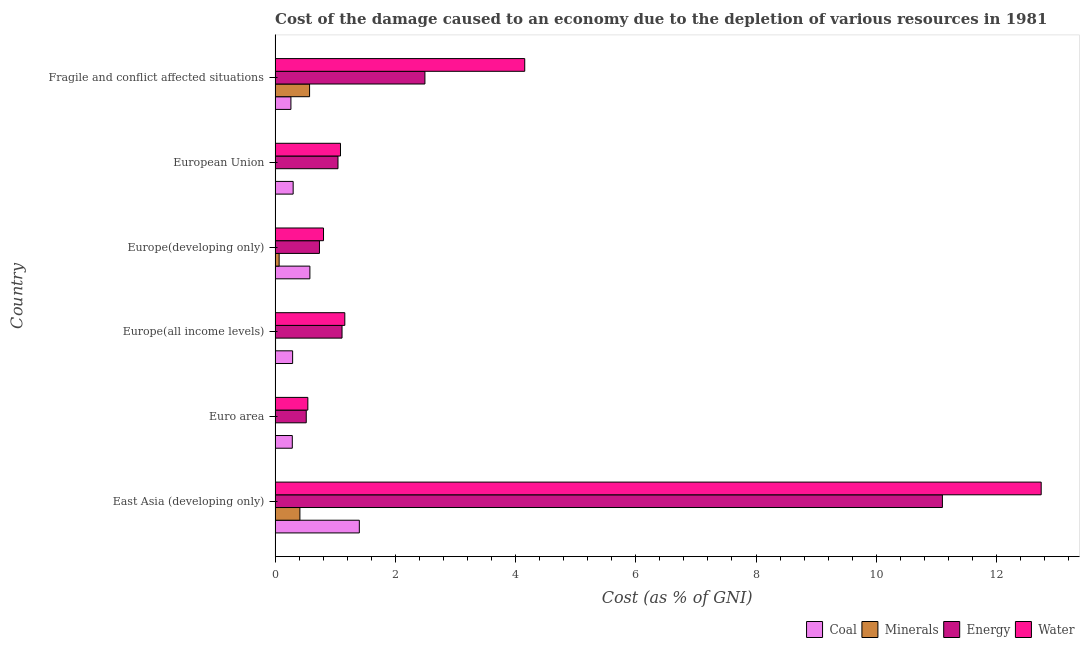How many groups of bars are there?
Offer a terse response. 6. Are the number of bars on each tick of the Y-axis equal?
Offer a terse response. Yes. How many bars are there on the 5th tick from the top?
Provide a short and direct response. 4. What is the label of the 4th group of bars from the top?
Make the answer very short. Europe(all income levels). What is the cost of damage due to depletion of minerals in European Union?
Make the answer very short. 0.01. Across all countries, what is the maximum cost of damage due to depletion of minerals?
Your answer should be very brief. 0.57. Across all countries, what is the minimum cost of damage due to depletion of water?
Ensure brevity in your answer.  0.54. In which country was the cost of damage due to depletion of water maximum?
Your response must be concise. East Asia (developing only). In which country was the cost of damage due to depletion of energy minimum?
Provide a short and direct response. Euro area. What is the total cost of damage due to depletion of minerals in the graph?
Make the answer very short. 1.07. What is the difference between the cost of damage due to depletion of water in Euro area and that in Europe(all income levels)?
Your response must be concise. -0.61. What is the difference between the cost of damage due to depletion of minerals in Europe(all income levels) and the cost of damage due to depletion of energy in East Asia (developing only)?
Your answer should be compact. -11.09. What is the average cost of damage due to depletion of energy per country?
Give a very brief answer. 2.83. What is the difference between the cost of damage due to depletion of energy and cost of damage due to depletion of water in Fragile and conflict affected situations?
Ensure brevity in your answer.  -1.66. In how many countries, is the cost of damage due to depletion of energy greater than 11.2 %?
Make the answer very short. 0. What is the ratio of the cost of damage due to depletion of coal in East Asia (developing only) to that in Europe(developing only)?
Provide a short and direct response. 2.42. Is the cost of damage due to depletion of water in Euro area less than that in Europe(all income levels)?
Offer a terse response. Yes. What is the difference between the highest and the second highest cost of damage due to depletion of water?
Ensure brevity in your answer.  8.59. What is the difference between the highest and the lowest cost of damage due to depletion of energy?
Offer a very short reply. 10.58. Is it the case that in every country, the sum of the cost of damage due to depletion of minerals and cost of damage due to depletion of coal is greater than the sum of cost of damage due to depletion of energy and cost of damage due to depletion of water?
Your answer should be compact. No. What does the 1st bar from the top in Fragile and conflict affected situations represents?
Keep it short and to the point. Water. What does the 4th bar from the bottom in Fragile and conflict affected situations represents?
Offer a very short reply. Water. How many countries are there in the graph?
Provide a short and direct response. 6. What is the difference between two consecutive major ticks on the X-axis?
Offer a very short reply. 2. Are the values on the major ticks of X-axis written in scientific E-notation?
Your answer should be compact. No. How many legend labels are there?
Your response must be concise. 4. What is the title of the graph?
Provide a succinct answer. Cost of the damage caused to an economy due to the depletion of various resources in 1981 . Does "International Monetary Fund" appear as one of the legend labels in the graph?
Offer a very short reply. No. What is the label or title of the X-axis?
Your response must be concise. Cost (as % of GNI). What is the Cost (as % of GNI) in Coal in East Asia (developing only)?
Ensure brevity in your answer.  1.4. What is the Cost (as % of GNI) of Minerals in East Asia (developing only)?
Ensure brevity in your answer.  0.41. What is the Cost (as % of GNI) in Energy in East Asia (developing only)?
Your answer should be compact. 11.1. What is the Cost (as % of GNI) of Water in East Asia (developing only)?
Keep it short and to the point. 12.74. What is the Cost (as % of GNI) of Coal in Euro area?
Give a very brief answer. 0.29. What is the Cost (as % of GNI) of Minerals in Euro area?
Give a very brief answer. 0.01. What is the Cost (as % of GNI) of Energy in Euro area?
Make the answer very short. 0.52. What is the Cost (as % of GNI) in Water in Euro area?
Your answer should be very brief. 0.54. What is the Cost (as % of GNI) of Coal in Europe(all income levels)?
Your answer should be compact. 0.29. What is the Cost (as % of GNI) in Minerals in Europe(all income levels)?
Your response must be concise. 0.01. What is the Cost (as % of GNI) in Energy in Europe(all income levels)?
Keep it short and to the point. 1.11. What is the Cost (as % of GNI) of Water in Europe(all income levels)?
Provide a short and direct response. 1.16. What is the Cost (as % of GNI) of Coal in Europe(developing only)?
Your answer should be compact. 0.58. What is the Cost (as % of GNI) in Minerals in Europe(developing only)?
Your response must be concise. 0.07. What is the Cost (as % of GNI) of Energy in Europe(developing only)?
Provide a succinct answer. 0.74. What is the Cost (as % of GNI) in Water in Europe(developing only)?
Your answer should be very brief. 0.81. What is the Cost (as % of GNI) in Coal in European Union?
Make the answer very short. 0.3. What is the Cost (as % of GNI) in Minerals in European Union?
Your answer should be very brief. 0.01. What is the Cost (as % of GNI) of Energy in European Union?
Your response must be concise. 1.05. What is the Cost (as % of GNI) in Water in European Union?
Keep it short and to the point. 1.09. What is the Cost (as % of GNI) of Coal in Fragile and conflict affected situations?
Offer a very short reply. 0.26. What is the Cost (as % of GNI) of Minerals in Fragile and conflict affected situations?
Give a very brief answer. 0.57. What is the Cost (as % of GNI) in Energy in Fragile and conflict affected situations?
Provide a short and direct response. 2.49. What is the Cost (as % of GNI) of Water in Fragile and conflict affected situations?
Your response must be concise. 4.15. Across all countries, what is the maximum Cost (as % of GNI) of Coal?
Your response must be concise. 1.4. Across all countries, what is the maximum Cost (as % of GNI) of Minerals?
Offer a very short reply. 0.57. Across all countries, what is the maximum Cost (as % of GNI) of Energy?
Keep it short and to the point. 11.1. Across all countries, what is the maximum Cost (as % of GNI) of Water?
Your response must be concise. 12.74. Across all countries, what is the minimum Cost (as % of GNI) of Coal?
Keep it short and to the point. 0.26. Across all countries, what is the minimum Cost (as % of GNI) in Minerals?
Provide a short and direct response. 0.01. Across all countries, what is the minimum Cost (as % of GNI) of Energy?
Keep it short and to the point. 0.52. Across all countries, what is the minimum Cost (as % of GNI) in Water?
Your response must be concise. 0.54. What is the total Cost (as % of GNI) of Coal in the graph?
Keep it short and to the point. 3.12. What is the total Cost (as % of GNI) in Minerals in the graph?
Provide a short and direct response. 1.07. What is the total Cost (as % of GNI) of Energy in the graph?
Ensure brevity in your answer.  17.01. What is the total Cost (as % of GNI) in Water in the graph?
Your answer should be compact. 20.49. What is the difference between the Cost (as % of GNI) in Coal in East Asia (developing only) and that in Euro area?
Provide a succinct answer. 1.11. What is the difference between the Cost (as % of GNI) in Minerals in East Asia (developing only) and that in Euro area?
Make the answer very short. 0.41. What is the difference between the Cost (as % of GNI) of Energy in East Asia (developing only) and that in Euro area?
Give a very brief answer. 10.58. What is the difference between the Cost (as % of GNI) of Water in East Asia (developing only) and that in Euro area?
Offer a very short reply. 12.2. What is the difference between the Cost (as % of GNI) in Coal in East Asia (developing only) and that in Europe(all income levels)?
Offer a terse response. 1.11. What is the difference between the Cost (as % of GNI) of Minerals in East Asia (developing only) and that in Europe(all income levels)?
Keep it short and to the point. 0.41. What is the difference between the Cost (as % of GNI) in Energy in East Asia (developing only) and that in Europe(all income levels)?
Offer a very short reply. 9.99. What is the difference between the Cost (as % of GNI) of Water in East Asia (developing only) and that in Europe(all income levels)?
Keep it short and to the point. 11.58. What is the difference between the Cost (as % of GNI) of Coal in East Asia (developing only) and that in Europe(developing only)?
Your answer should be compact. 0.82. What is the difference between the Cost (as % of GNI) in Minerals in East Asia (developing only) and that in Europe(developing only)?
Your answer should be very brief. 0.35. What is the difference between the Cost (as % of GNI) of Energy in East Asia (developing only) and that in Europe(developing only)?
Provide a succinct answer. 10.36. What is the difference between the Cost (as % of GNI) in Water in East Asia (developing only) and that in Europe(developing only)?
Give a very brief answer. 11.94. What is the difference between the Cost (as % of GNI) of Coal in East Asia (developing only) and that in European Union?
Provide a succinct answer. 1.1. What is the difference between the Cost (as % of GNI) of Minerals in East Asia (developing only) and that in European Union?
Provide a short and direct response. 0.41. What is the difference between the Cost (as % of GNI) of Energy in East Asia (developing only) and that in European Union?
Provide a succinct answer. 10.05. What is the difference between the Cost (as % of GNI) of Water in East Asia (developing only) and that in European Union?
Provide a short and direct response. 11.66. What is the difference between the Cost (as % of GNI) in Coal in East Asia (developing only) and that in Fragile and conflict affected situations?
Provide a succinct answer. 1.14. What is the difference between the Cost (as % of GNI) of Minerals in East Asia (developing only) and that in Fragile and conflict affected situations?
Provide a succinct answer. -0.16. What is the difference between the Cost (as % of GNI) in Energy in East Asia (developing only) and that in Fragile and conflict affected situations?
Your answer should be compact. 8.61. What is the difference between the Cost (as % of GNI) of Water in East Asia (developing only) and that in Fragile and conflict affected situations?
Your answer should be very brief. 8.59. What is the difference between the Cost (as % of GNI) in Coal in Euro area and that in Europe(all income levels)?
Provide a short and direct response. -0.01. What is the difference between the Cost (as % of GNI) in Minerals in Euro area and that in Europe(all income levels)?
Provide a short and direct response. -0. What is the difference between the Cost (as % of GNI) of Energy in Euro area and that in Europe(all income levels)?
Provide a succinct answer. -0.6. What is the difference between the Cost (as % of GNI) in Water in Euro area and that in Europe(all income levels)?
Your answer should be very brief. -0.61. What is the difference between the Cost (as % of GNI) of Coal in Euro area and that in Europe(developing only)?
Provide a succinct answer. -0.29. What is the difference between the Cost (as % of GNI) of Minerals in Euro area and that in Europe(developing only)?
Make the answer very short. -0.06. What is the difference between the Cost (as % of GNI) of Energy in Euro area and that in Europe(developing only)?
Ensure brevity in your answer.  -0.22. What is the difference between the Cost (as % of GNI) in Water in Euro area and that in Europe(developing only)?
Make the answer very short. -0.26. What is the difference between the Cost (as % of GNI) in Coal in Euro area and that in European Union?
Provide a short and direct response. -0.01. What is the difference between the Cost (as % of GNI) in Minerals in Euro area and that in European Union?
Your answer should be very brief. -0. What is the difference between the Cost (as % of GNI) in Energy in Euro area and that in European Union?
Ensure brevity in your answer.  -0.53. What is the difference between the Cost (as % of GNI) in Water in Euro area and that in European Union?
Offer a very short reply. -0.54. What is the difference between the Cost (as % of GNI) of Coal in Euro area and that in Fragile and conflict affected situations?
Your answer should be compact. 0.02. What is the difference between the Cost (as % of GNI) in Minerals in Euro area and that in Fragile and conflict affected situations?
Give a very brief answer. -0.57. What is the difference between the Cost (as % of GNI) of Energy in Euro area and that in Fragile and conflict affected situations?
Provide a succinct answer. -1.97. What is the difference between the Cost (as % of GNI) in Water in Euro area and that in Fragile and conflict affected situations?
Give a very brief answer. -3.61. What is the difference between the Cost (as % of GNI) of Coal in Europe(all income levels) and that in Europe(developing only)?
Provide a succinct answer. -0.29. What is the difference between the Cost (as % of GNI) in Minerals in Europe(all income levels) and that in Europe(developing only)?
Give a very brief answer. -0.06. What is the difference between the Cost (as % of GNI) of Energy in Europe(all income levels) and that in Europe(developing only)?
Ensure brevity in your answer.  0.38. What is the difference between the Cost (as % of GNI) in Water in Europe(all income levels) and that in Europe(developing only)?
Offer a terse response. 0.35. What is the difference between the Cost (as % of GNI) in Coal in Europe(all income levels) and that in European Union?
Provide a short and direct response. -0.01. What is the difference between the Cost (as % of GNI) of Minerals in Europe(all income levels) and that in European Union?
Provide a short and direct response. 0. What is the difference between the Cost (as % of GNI) in Energy in Europe(all income levels) and that in European Union?
Your answer should be very brief. 0.07. What is the difference between the Cost (as % of GNI) in Water in Europe(all income levels) and that in European Union?
Ensure brevity in your answer.  0.07. What is the difference between the Cost (as % of GNI) of Coal in Europe(all income levels) and that in Fragile and conflict affected situations?
Your response must be concise. 0.03. What is the difference between the Cost (as % of GNI) of Minerals in Europe(all income levels) and that in Fragile and conflict affected situations?
Offer a terse response. -0.57. What is the difference between the Cost (as % of GNI) of Energy in Europe(all income levels) and that in Fragile and conflict affected situations?
Provide a succinct answer. -1.38. What is the difference between the Cost (as % of GNI) of Water in Europe(all income levels) and that in Fragile and conflict affected situations?
Give a very brief answer. -2.99. What is the difference between the Cost (as % of GNI) of Coal in Europe(developing only) and that in European Union?
Offer a terse response. 0.28. What is the difference between the Cost (as % of GNI) of Minerals in Europe(developing only) and that in European Union?
Your answer should be compact. 0.06. What is the difference between the Cost (as % of GNI) of Energy in Europe(developing only) and that in European Union?
Make the answer very short. -0.31. What is the difference between the Cost (as % of GNI) of Water in Europe(developing only) and that in European Union?
Offer a terse response. -0.28. What is the difference between the Cost (as % of GNI) in Coal in Europe(developing only) and that in Fragile and conflict affected situations?
Your response must be concise. 0.32. What is the difference between the Cost (as % of GNI) in Minerals in Europe(developing only) and that in Fragile and conflict affected situations?
Your answer should be very brief. -0.51. What is the difference between the Cost (as % of GNI) of Energy in Europe(developing only) and that in Fragile and conflict affected situations?
Your response must be concise. -1.75. What is the difference between the Cost (as % of GNI) of Water in Europe(developing only) and that in Fragile and conflict affected situations?
Provide a succinct answer. -3.35. What is the difference between the Cost (as % of GNI) in Coal in European Union and that in Fragile and conflict affected situations?
Provide a short and direct response. 0.04. What is the difference between the Cost (as % of GNI) in Minerals in European Union and that in Fragile and conflict affected situations?
Your response must be concise. -0.57. What is the difference between the Cost (as % of GNI) of Energy in European Union and that in Fragile and conflict affected situations?
Your response must be concise. -1.45. What is the difference between the Cost (as % of GNI) in Water in European Union and that in Fragile and conflict affected situations?
Provide a succinct answer. -3.06. What is the difference between the Cost (as % of GNI) in Coal in East Asia (developing only) and the Cost (as % of GNI) in Minerals in Euro area?
Offer a terse response. 1.4. What is the difference between the Cost (as % of GNI) of Coal in East Asia (developing only) and the Cost (as % of GNI) of Energy in Euro area?
Your answer should be very brief. 0.88. What is the difference between the Cost (as % of GNI) of Coal in East Asia (developing only) and the Cost (as % of GNI) of Water in Euro area?
Your answer should be compact. 0.86. What is the difference between the Cost (as % of GNI) in Minerals in East Asia (developing only) and the Cost (as % of GNI) in Energy in Euro area?
Provide a succinct answer. -0.11. What is the difference between the Cost (as % of GNI) in Minerals in East Asia (developing only) and the Cost (as % of GNI) in Water in Euro area?
Your response must be concise. -0.13. What is the difference between the Cost (as % of GNI) in Energy in East Asia (developing only) and the Cost (as % of GNI) in Water in Euro area?
Make the answer very short. 10.55. What is the difference between the Cost (as % of GNI) in Coal in East Asia (developing only) and the Cost (as % of GNI) in Minerals in Europe(all income levels)?
Keep it short and to the point. 1.39. What is the difference between the Cost (as % of GNI) of Coal in East Asia (developing only) and the Cost (as % of GNI) of Energy in Europe(all income levels)?
Keep it short and to the point. 0.29. What is the difference between the Cost (as % of GNI) of Coal in East Asia (developing only) and the Cost (as % of GNI) of Water in Europe(all income levels)?
Provide a succinct answer. 0.24. What is the difference between the Cost (as % of GNI) in Minerals in East Asia (developing only) and the Cost (as % of GNI) in Energy in Europe(all income levels)?
Keep it short and to the point. -0.7. What is the difference between the Cost (as % of GNI) of Minerals in East Asia (developing only) and the Cost (as % of GNI) of Water in Europe(all income levels)?
Offer a terse response. -0.75. What is the difference between the Cost (as % of GNI) in Energy in East Asia (developing only) and the Cost (as % of GNI) in Water in Europe(all income levels)?
Keep it short and to the point. 9.94. What is the difference between the Cost (as % of GNI) of Coal in East Asia (developing only) and the Cost (as % of GNI) of Minerals in Europe(developing only)?
Keep it short and to the point. 1.33. What is the difference between the Cost (as % of GNI) in Coal in East Asia (developing only) and the Cost (as % of GNI) in Energy in Europe(developing only)?
Offer a terse response. 0.66. What is the difference between the Cost (as % of GNI) in Coal in East Asia (developing only) and the Cost (as % of GNI) in Water in Europe(developing only)?
Make the answer very short. 0.6. What is the difference between the Cost (as % of GNI) in Minerals in East Asia (developing only) and the Cost (as % of GNI) in Energy in Europe(developing only)?
Make the answer very short. -0.33. What is the difference between the Cost (as % of GNI) of Minerals in East Asia (developing only) and the Cost (as % of GNI) of Water in Europe(developing only)?
Provide a succinct answer. -0.39. What is the difference between the Cost (as % of GNI) of Energy in East Asia (developing only) and the Cost (as % of GNI) of Water in Europe(developing only)?
Offer a terse response. 10.29. What is the difference between the Cost (as % of GNI) in Coal in East Asia (developing only) and the Cost (as % of GNI) in Minerals in European Union?
Provide a short and direct response. 1.39. What is the difference between the Cost (as % of GNI) in Coal in East Asia (developing only) and the Cost (as % of GNI) in Energy in European Union?
Your answer should be compact. 0.36. What is the difference between the Cost (as % of GNI) of Coal in East Asia (developing only) and the Cost (as % of GNI) of Water in European Union?
Offer a terse response. 0.31. What is the difference between the Cost (as % of GNI) in Minerals in East Asia (developing only) and the Cost (as % of GNI) in Energy in European Union?
Offer a terse response. -0.63. What is the difference between the Cost (as % of GNI) of Minerals in East Asia (developing only) and the Cost (as % of GNI) of Water in European Union?
Make the answer very short. -0.68. What is the difference between the Cost (as % of GNI) of Energy in East Asia (developing only) and the Cost (as % of GNI) of Water in European Union?
Your answer should be very brief. 10.01. What is the difference between the Cost (as % of GNI) in Coal in East Asia (developing only) and the Cost (as % of GNI) in Minerals in Fragile and conflict affected situations?
Offer a very short reply. 0.83. What is the difference between the Cost (as % of GNI) of Coal in East Asia (developing only) and the Cost (as % of GNI) of Energy in Fragile and conflict affected situations?
Ensure brevity in your answer.  -1.09. What is the difference between the Cost (as % of GNI) in Coal in East Asia (developing only) and the Cost (as % of GNI) in Water in Fragile and conflict affected situations?
Offer a very short reply. -2.75. What is the difference between the Cost (as % of GNI) in Minerals in East Asia (developing only) and the Cost (as % of GNI) in Energy in Fragile and conflict affected situations?
Offer a terse response. -2.08. What is the difference between the Cost (as % of GNI) in Minerals in East Asia (developing only) and the Cost (as % of GNI) in Water in Fragile and conflict affected situations?
Ensure brevity in your answer.  -3.74. What is the difference between the Cost (as % of GNI) in Energy in East Asia (developing only) and the Cost (as % of GNI) in Water in Fragile and conflict affected situations?
Offer a terse response. 6.95. What is the difference between the Cost (as % of GNI) in Coal in Euro area and the Cost (as % of GNI) in Minerals in Europe(all income levels)?
Offer a very short reply. 0.28. What is the difference between the Cost (as % of GNI) in Coal in Euro area and the Cost (as % of GNI) in Energy in Europe(all income levels)?
Your answer should be compact. -0.83. What is the difference between the Cost (as % of GNI) of Coal in Euro area and the Cost (as % of GNI) of Water in Europe(all income levels)?
Your answer should be compact. -0.87. What is the difference between the Cost (as % of GNI) in Minerals in Euro area and the Cost (as % of GNI) in Energy in Europe(all income levels)?
Provide a short and direct response. -1.11. What is the difference between the Cost (as % of GNI) in Minerals in Euro area and the Cost (as % of GNI) in Water in Europe(all income levels)?
Offer a terse response. -1.15. What is the difference between the Cost (as % of GNI) of Energy in Euro area and the Cost (as % of GNI) of Water in Europe(all income levels)?
Your answer should be very brief. -0.64. What is the difference between the Cost (as % of GNI) of Coal in Euro area and the Cost (as % of GNI) of Minerals in Europe(developing only)?
Keep it short and to the point. 0.22. What is the difference between the Cost (as % of GNI) in Coal in Euro area and the Cost (as % of GNI) in Energy in Europe(developing only)?
Keep it short and to the point. -0.45. What is the difference between the Cost (as % of GNI) in Coal in Euro area and the Cost (as % of GNI) in Water in Europe(developing only)?
Keep it short and to the point. -0.52. What is the difference between the Cost (as % of GNI) of Minerals in Euro area and the Cost (as % of GNI) of Energy in Europe(developing only)?
Keep it short and to the point. -0.73. What is the difference between the Cost (as % of GNI) in Minerals in Euro area and the Cost (as % of GNI) in Water in Europe(developing only)?
Keep it short and to the point. -0.8. What is the difference between the Cost (as % of GNI) of Energy in Euro area and the Cost (as % of GNI) of Water in Europe(developing only)?
Your answer should be very brief. -0.29. What is the difference between the Cost (as % of GNI) in Coal in Euro area and the Cost (as % of GNI) in Minerals in European Union?
Ensure brevity in your answer.  0.28. What is the difference between the Cost (as % of GNI) in Coal in Euro area and the Cost (as % of GNI) in Energy in European Union?
Offer a terse response. -0.76. What is the difference between the Cost (as % of GNI) in Coal in Euro area and the Cost (as % of GNI) in Water in European Union?
Ensure brevity in your answer.  -0.8. What is the difference between the Cost (as % of GNI) in Minerals in Euro area and the Cost (as % of GNI) in Energy in European Union?
Your answer should be very brief. -1.04. What is the difference between the Cost (as % of GNI) in Minerals in Euro area and the Cost (as % of GNI) in Water in European Union?
Offer a terse response. -1.08. What is the difference between the Cost (as % of GNI) of Energy in Euro area and the Cost (as % of GNI) of Water in European Union?
Provide a short and direct response. -0.57. What is the difference between the Cost (as % of GNI) of Coal in Euro area and the Cost (as % of GNI) of Minerals in Fragile and conflict affected situations?
Your answer should be compact. -0.29. What is the difference between the Cost (as % of GNI) of Coal in Euro area and the Cost (as % of GNI) of Energy in Fragile and conflict affected situations?
Provide a succinct answer. -2.21. What is the difference between the Cost (as % of GNI) of Coal in Euro area and the Cost (as % of GNI) of Water in Fragile and conflict affected situations?
Your answer should be very brief. -3.87. What is the difference between the Cost (as % of GNI) in Minerals in Euro area and the Cost (as % of GNI) in Energy in Fragile and conflict affected situations?
Give a very brief answer. -2.49. What is the difference between the Cost (as % of GNI) of Minerals in Euro area and the Cost (as % of GNI) of Water in Fragile and conflict affected situations?
Your answer should be compact. -4.15. What is the difference between the Cost (as % of GNI) in Energy in Euro area and the Cost (as % of GNI) in Water in Fragile and conflict affected situations?
Ensure brevity in your answer.  -3.63. What is the difference between the Cost (as % of GNI) in Coal in Europe(all income levels) and the Cost (as % of GNI) in Minerals in Europe(developing only)?
Your answer should be compact. 0.22. What is the difference between the Cost (as % of GNI) of Coal in Europe(all income levels) and the Cost (as % of GNI) of Energy in Europe(developing only)?
Offer a terse response. -0.45. What is the difference between the Cost (as % of GNI) in Coal in Europe(all income levels) and the Cost (as % of GNI) in Water in Europe(developing only)?
Ensure brevity in your answer.  -0.51. What is the difference between the Cost (as % of GNI) of Minerals in Europe(all income levels) and the Cost (as % of GNI) of Energy in Europe(developing only)?
Provide a succinct answer. -0.73. What is the difference between the Cost (as % of GNI) of Minerals in Europe(all income levels) and the Cost (as % of GNI) of Water in Europe(developing only)?
Provide a short and direct response. -0.8. What is the difference between the Cost (as % of GNI) of Energy in Europe(all income levels) and the Cost (as % of GNI) of Water in Europe(developing only)?
Your answer should be very brief. 0.31. What is the difference between the Cost (as % of GNI) in Coal in Europe(all income levels) and the Cost (as % of GNI) in Minerals in European Union?
Provide a short and direct response. 0.28. What is the difference between the Cost (as % of GNI) of Coal in Europe(all income levels) and the Cost (as % of GNI) of Energy in European Union?
Make the answer very short. -0.75. What is the difference between the Cost (as % of GNI) in Coal in Europe(all income levels) and the Cost (as % of GNI) in Water in European Union?
Give a very brief answer. -0.8. What is the difference between the Cost (as % of GNI) in Minerals in Europe(all income levels) and the Cost (as % of GNI) in Energy in European Union?
Provide a succinct answer. -1.04. What is the difference between the Cost (as % of GNI) of Minerals in Europe(all income levels) and the Cost (as % of GNI) of Water in European Union?
Your answer should be very brief. -1.08. What is the difference between the Cost (as % of GNI) of Energy in Europe(all income levels) and the Cost (as % of GNI) of Water in European Union?
Keep it short and to the point. 0.03. What is the difference between the Cost (as % of GNI) of Coal in Europe(all income levels) and the Cost (as % of GNI) of Minerals in Fragile and conflict affected situations?
Keep it short and to the point. -0.28. What is the difference between the Cost (as % of GNI) in Coal in Europe(all income levels) and the Cost (as % of GNI) in Energy in Fragile and conflict affected situations?
Your response must be concise. -2.2. What is the difference between the Cost (as % of GNI) in Coal in Europe(all income levels) and the Cost (as % of GNI) in Water in Fragile and conflict affected situations?
Your answer should be compact. -3.86. What is the difference between the Cost (as % of GNI) in Minerals in Europe(all income levels) and the Cost (as % of GNI) in Energy in Fragile and conflict affected situations?
Your answer should be compact. -2.48. What is the difference between the Cost (as % of GNI) in Minerals in Europe(all income levels) and the Cost (as % of GNI) in Water in Fragile and conflict affected situations?
Provide a short and direct response. -4.14. What is the difference between the Cost (as % of GNI) in Energy in Europe(all income levels) and the Cost (as % of GNI) in Water in Fragile and conflict affected situations?
Keep it short and to the point. -3.04. What is the difference between the Cost (as % of GNI) of Coal in Europe(developing only) and the Cost (as % of GNI) of Minerals in European Union?
Your response must be concise. 0.57. What is the difference between the Cost (as % of GNI) in Coal in Europe(developing only) and the Cost (as % of GNI) in Energy in European Union?
Your response must be concise. -0.47. What is the difference between the Cost (as % of GNI) of Coal in Europe(developing only) and the Cost (as % of GNI) of Water in European Union?
Your answer should be compact. -0.51. What is the difference between the Cost (as % of GNI) in Minerals in Europe(developing only) and the Cost (as % of GNI) in Energy in European Union?
Offer a very short reply. -0.98. What is the difference between the Cost (as % of GNI) of Minerals in Europe(developing only) and the Cost (as % of GNI) of Water in European Union?
Keep it short and to the point. -1.02. What is the difference between the Cost (as % of GNI) of Energy in Europe(developing only) and the Cost (as % of GNI) of Water in European Union?
Give a very brief answer. -0.35. What is the difference between the Cost (as % of GNI) of Coal in Europe(developing only) and the Cost (as % of GNI) of Minerals in Fragile and conflict affected situations?
Give a very brief answer. 0.01. What is the difference between the Cost (as % of GNI) of Coal in Europe(developing only) and the Cost (as % of GNI) of Energy in Fragile and conflict affected situations?
Keep it short and to the point. -1.91. What is the difference between the Cost (as % of GNI) in Coal in Europe(developing only) and the Cost (as % of GNI) in Water in Fragile and conflict affected situations?
Give a very brief answer. -3.57. What is the difference between the Cost (as % of GNI) of Minerals in Europe(developing only) and the Cost (as % of GNI) of Energy in Fragile and conflict affected situations?
Offer a very short reply. -2.42. What is the difference between the Cost (as % of GNI) in Minerals in Europe(developing only) and the Cost (as % of GNI) in Water in Fragile and conflict affected situations?
Ensure brevity in your answer.  -4.09. What is the difference between the Cost (as % of GNI) of Energy in Europe(developing only) and the Cost (as % of GNI) of Water in Fragile and conflict affected situations?
Offer a terse response. -3.41. What is the difference between the Cost (as % of GNI) in Coal in European Union and the Cost (as % of GNI) in Minerals in Fragile and conflict affected situations?
Your response must be concise. -0.27. What is the difference between the Cost (as % of GNI) in Coal in European Union and the Cost (as % of GNI) in Energy in Fragile and conflict affected situations?
Give a very brief answer. -2.19. What is the difference between the Cost (as % of GNI) in Coal in European Union and the Cost (as % of GNI) in Water in Fragile and conflict affected situations?
Your answer should be compact. -3.85. What is the difference between the Cost (as % of GNI) of Minerals in European Union and the Cost (as % of GNI) of Energy in Fragile and conflict affected situations?
Your response must be concise. -2.49. What is the difference between the Cost (as % of GNI) of Minerals in European Union and the Cost (as % of GNI) of Water in Fragile and conflict affected situations?
Your response must be concise. -4.15. What is the difference between the Cost (as % of GNI) of Energy in European Union and the Cost (as % of GNI) of Water in Fragile and conflict affected situations?
Provide a succinct answer. -3.11. What is the average Cost (as % of GNI) in Coal per country?
Your answer should be compact. 0.52. What is the average Cost (as % of GNI) in Minerals per country?
Offer a very short reply. 0.18. What is the average Cost (as % of GNI) in Energy per country?
Provide a short and direct response. 2.83. What is the average Cost (as % of GNI) of Water per country?
Keep it short and to the point. 3.42. What is the difference between the Cost (as % of GNI) of Coal and Cost (as % of GNI) of Minerals in East Asia (developing only)?
Offer a very short reply. 0.99. What is the difference between the Cost (as % of GNI) of Coal and Cost (as % of GNI) of Energy in East Asia (developing only)?
Your answer should be compact. -9.7. What is the difference between the Cost (as % of GNI) in Coal and Cost (as % of GNI) in Water in East Asia (developing only)?
Offer a terse response. -11.34. What is the difference between the Cost (as % of GNI) in Minerals and Cost (as % of GNI) in Energy in East Asia (developing only)?
Offer a terse response. -10.69. What is the difference between the Cost (as % of GNI) in Minerals and Cost (as % of GNI) in Water in East Asia (developing only)?
Provide a succinct answer. -12.33. What is the difference between the Cost (as % of GNI) in Energy and Cost (as % of GNI) in Water in East Asia (developing only)?
Ensure brevity in your answer.  -1.64. What is the difference between the Cost (as % of GNI) in Coal and Cost (as % of GNI) in Minerals in Euro area?
Make the answer very short. 0.28. What is the difference between the Cost (as % of GNI) in Coal and Cost (as % of GNI) in Energy in Euro area?
Make the answer very short. -0.23. What is the difference between the Cost (as % of GNI) of Coal and Cost (as % of GNI) of Water in Euro area?
Ensure brevity in your answer.  -0.26. What is the difference between the Cost (as % of GNI) of Minerals and Cost (as % of GNI) of Energy in Euro area?
Offer a very short reply. -0.51. What is the difference between the Cost (as % of GNI) of Minerals and Cost (as % of GNI) of Water in Euro area?
Offer a very short reply. -0.54. What is the difference between the Cost (as % of GNI) in Energy and Cost (as % of GNI) in Water in Euro area?
Give a very brief answer. -0.03. What is the difference between the Cost (as % of GNI) of Coal and Cost (as % of GNI) of Minerals in Europe(all income levels)?
Offer a very short reply. 0.28. What is the difference between the Cost (as % of GNI) in Coal and Cost (as % of GNI) in Energy in Europe(all income levels)?
Provide a succinct answer. -0.82. What is the difference between the Cost (as % of GNI) in Coal and Cost (as % of GNI) in Water in Europe(all income levels)?
Provide a succinct answer. -0.87. What is the difference between the Cost (as % of GNI) in Minerals and Cost (as % of GNI) in Energy in Europe(all income levels)?
Make the answer very short. -1.11. What is the difference between the Cost (as % of GNI) of Minerals and Cost (as % of GNI) of Water in Europe(all income levels)?
Ensure brevity in your answer.  -1.15. What is the difference between the Cost (as % of GNI) of Energy and Cost (as % of GNI) of Water in Europe(all income levels)?
Your answer should be very brief. -0.05. What is the difference between the Cost (as % of GNI) of Coal and Cost (as % of GNI) of Minerals in Europe(developing only)?
Your answer should be very brief. 0.51. What is the difference between the Cost (as % of GNI) of Coal and Cost (as % of GNI) of Energy in Europe(developing only)?
Offer a terse response. -0.16. What is the difference between the Cost (as % of GNI) of Coal and Cost (as % of GNI) of Water in Europe(developing only)?
Give a very brief answer. -0.23. What is the difference between the Cost (as % of GNI) in Minerals and Cost (as % of GNI) in Energy in Europe(developing only)?
Keep it short and to the point. -0.67. What is the difference between the Cost (as % of GNI) in Minerals and Cost (as % of GNI) in Water in Europe(developing only)?
Your answer should be compact. -0.74. What is the difference between the Cost (as % of GNI) in Energy and Cost (as % of GNI) in Water in Europe(developing only)?
Provide a succinct answer. -0.07. What is the difference between the Cost (as % of GNI) in Coal and Cost (as % of GNI) in Minerals in European Union?
Ensure brevity in your answer.  0.29. What is the difference between the Cost (as % of GNI) of Coal and Cost (as % of GNI) of Energy in European Union?
Offer a terse response. -0.75. What is the difference between the Cost (as % of GNI) in Coal and Cost (as % of GNI) in Water in European Union?
Provide a succinct answer. -0.79. What is the difference between the Cost (as % of GNI) in Minerals and Cost (as % of GNI) in Energy in European Union?
Offer a terse response. -1.04. What is the difference between the Cost (as % of GNI) in Minerals and Cost (as % of GNI) in Water in European Union?
Ensure brevity in your answer.  -1.08. What is the difference between the Cost (as % of GNI) in Energy and Cost (as % of GNI) in Water in European Union?
Your response must be concise. -0.04. What is the difference between the Cost (as % of GNI) in Coal and Cost (as % of GNI) in Minerals in Fragile and conflict affected situations?
Your response must be concise. -0.31. What is the difference between the Cost (as % of GNI) of Coal and Cost (as % of GNI) of Energy in Fragile and conflict affected situations?
Make the answer very short. -2.23. What is the difference between the Cost (as % of GNI) in Coal and Cost (as % of GNI) in Water in Fragile and conflict affected situations?
Provide a succinct answer. -3.89. What is the difference between the Cost (as % of GNI) in Minerals and Cost (as % of GNI) in Energy in Fragile and conflict affected situations?
Your response must be concise. -1.92. What is the difference between the Cost (as % of GNI) in Minerals and Cost (as % of GNI) in Water in Fragile and conflict affected situations?
Your response must be concise. -3.58. What is the difference between the Cost (as % of GNI) of Energy and Cost (as % of GNI) of Water in Fragile and conflict affected situations?
Provide a short and direct response. -1.66. What is the ratio of the Cost (as % of GNI) of Coal in East Asia (developing only) to that in Euro area?
Make the answer very short. 4.89. What is the ratio of the Cost (as % of GNI) of Minerals in East Asia (developing only) to that in Euro area?
Provide a succinct answer. 71.22. What is the ratio of the Cost (as % of GNI) in Energy in East Asia (developing only) to that in Euro area?
Keep it short and to the point. 21.41. What is the ratio of the Cost (as % of GNI) of Water in East Asia (developing only) to that in Euro area?
Offer a terse response. 23.38. What is the ratio of the Cost (as % of GNI) in Coal in East Asia (developing only) to that in Europe(all income levels)?
Provide a short and direct response. 4.8. What is the ratio of the Cost (as % of GNI) in Minerals in East Asia (developing only) to that in Europe(all income levels)?
Make the answer very short. 53.05. What is the ratio of the Cost (as % of GNI) in Energy in East Asia (developing only) to that in Europe(all income levels)?
Your answer should be compact. 9.97. What is the ratio of the Cost (as % of GNI) in Water in East Asia (developing only) to that in Europe(all income levels)?
Your response must be concise. 10.99. What is the ratio of the Cost (as % of GNI) of Coal in East Asia (developing only) to that in Europe(developing only)?
Offer a terse response. 2.42. What is the ratio of the Cost (as % of GNI) in Minerals in East Asia (developing only) to that in Europe(developing only)?
Offer a terse response. 6.12. What is the ratio of the Cost (as % of GNI) in Energy in East Asia (developing only) to that in Europe(developing only)?
Your response must be concise. 15.04. What is the ratio of the Cost (as % of GNI) of Water in East Asia (developing only) to that in Europe(developing only)?
Your response must be concise. 15.82. What is the ratio of the Cost (as % of GNI) of Coal in East Asia (developing only) to that in European Union?
Offer a very short reply. 4.66. What is the ratio of the Cost (as % of GNI) of Minerals in East Asia (developing only) to that in European Union?
Keep it short and to the point. 57.56. What is the ratio of the Cost (as % of GNI) of Energy in East Asia (developing only) to that in European Union?
Offer a very short reply. 10.61. What is the ratio of the Cost (as % of GNI) of Water in East Asia (developing only) to that in European Union?
Your answer should be compact. 11.71. What is the ratio of the Cost (as % of GNI) of Coal in East Asia (developing only) to that in Fragile and conflict affected situations?
Keep it short and to the point. 5.32. What is the ratio of the Cost (as % of GNI) in Minerals in East Asia (developing only) to that in Fragile and conflict affected situations?
Make the answer very short. 0.72. What is the ratio of the Cost (as % of GNI) of Energy in East Asia (developing only) to that in Fragile and conflict affected situations?
Offer a very short reply. 4.45. What is the ratio of the Cost (as % of GNI) of Water in East Asia (developing only) to that in Fragile and conflict affected situations?
Give a very brief answer. 3.07. What is the ratio of the Cost (as % of GNI) of Coal in Euro area to that in Europe(all income levels)?
Offer a terse response. 0.98. What is the ratio of the Cost (as % of GNI) of Minerals in Euro area to that in Europe(all income levels)?
Give a very brief answer. 0.74. What is the ratio of the Cost (as % of GNI) of Energy in Euro area to that in Europe(all income levels)?
Make the answer very short. 0.47. What is the ratio of the Cost (as % of GNI) of Water in Euro area to that in Europe(all income levels)?
Your answer should be compact. 0.47. What is the ratio of the Cost (as % of GNI) of Coal in Euro area to that in Europe(developing only)?
Your answer should be compact. 0.49. What is the ratio of the Cost (as % of GNI) of Minerals in Euro area to that in Europe(developing only)?
Provide a short and direct response. 0.09. What is the ratio of the Cost (as % of GNI) in Energy in Euro area to that in Europe(developing only)?
Offer a terse response. 0.7. What is the ratio of the Cost (as % of GNI) in Water in Euro area to that in Europe(developing only)?
Make the answer very short. 0.68. What is the ratio of the Cost (as % of GNI) of Coal in Euro area to that in European Union?
Your answer should be compact. 0.95. What is the ratio of the Cost (as % of GNI) in Minerals in Euro area to that in European Union?
Offer a terse response. 0.81. What is the ratio of the Cost (as % of GNI) of Energy in Euro area to that in European Union?
Make the answer very short. 0.5. What is the ratio of the Cost (as % of GNI) of Water in Euro area to that in European Union?
Your response must be concise. 0.5. What is the ratio of the Cost (as % of GNI) in Coal in Euro area to that in Fragile and conflict affected situations?
Provide a succinct answer. 1.09. What is the ratio of the Cost (as % of GNI) in Minerals in Euro area to that in Fragile and conflict affected situations?
Keep it short and to the point. 0.01. What is the ratio of the Cost (as % of GNI) in Energy in Euro area to that in Fragile and conflict affected situations?
Ensure brevity in your answer.  0.21. What is the ratio of the Cost (as % of GNI) in Water in Euro area to that in Fragile and conflict affected situations?
Ensure brevity in your answer.  0.13. What is the ratio of the Cost (as % of GNI) in Coal in Europe(all income levels) to that in Europe(developing only)?
Offer a very short reply. 0.5. What is the ratio of the Cost (as % of GNI) in Minerals in Europe(all income levels) to that in Europe(developing only)?
Your response must be concise. 0.12. What is the ratio of the Cost (as % of GNI) in Energy in Europe(all income levels) to that in Europe(developing only)?
Your answer should be very brief. 1.51. What is the ratio of the Cost (as % of GNI) in Water in Europe(all income levels) to that in Europe(developing only)?
Offer a very short reply. 1.44. What is the ratio of the Cost (as % of GNI) of Coal in Europe(all income levels) to that in European Union?
Provide a succinct answer. 0.97. What is the ratio of the Cost (as % of GNI) in Minerals in Europe(all income levels) to that in European Union?
Your answer should be very brief. 1.09. What is the ratio of the Cost (as % of GNI) of Energy in Europe(all income levels) to that in European Union?
Give a very brief answer. 1.06. What is the ratio of the Cost (as % of GNI) in Water in Europe(all income levels) to that in European Union?
Make the answer very short. 1.07. What is the ratio of the Cost (as % of GNI) of Coal in Europe(all income levels) to that in Fragile and conflict affected situations?
Ensure brevity in your answer.  1.11. What is the ratio of the Cost (as % of GNI) in Minerals in Europe(all income levels) to that in Fragile and conflict affected situations?
Ensure brevity in your answer.  0.01. What is the ratio of the Cost (as % of GNI) in Energy in Europe(all income levels) to that in Fragile and conflict affected situations?
Your response must be concise. 0.45. What is the ratio of the Cost (as % of GNI) in Water in Europe(all income levels) to that in Fragile and conflict affected situations?
Keep it short and to the point. 0.28. What is the ratio of the Cost (as % of GNI) of Coal in Europe(developing only) to that in European Union?
Provide a succinct answer. 1.93. What is the ratio of the Cost (as % of GNI) of Minerals in Europe(developing only) to that in European Union?
Offer a terse response. 9.4. What is the ratio of the Cost (as % of GNI) in Energy in Europe(developing only) to that in European Union?
Offer a terse response. 0.71. What is the ratio of the Cost (as % of GNI) of Water in Europe(developing only) to that in European Union?
Give a very brief answer. 0.74. What is the ratio of the Cost (as % of GNI) in Coal in Europe(developing only) to that in Fragile and conflict affected situations?
Your answer should be very brief. 2.2. What is the ratio of the Cost (as % of GNI) of Minerals in Europe(developing only) to that in Fragile and conflict affected situations?
Your answer should be very brief. 0.12. What is the ratio of the Cost (as % of GNI) of Energy in Europe(developing only) to that in Fragile and conflict affected situations?
Your answer should be compact. 0.3. What is the ratio of the Cost (as % of GNI) in Water in Europe(developing only) to that in Fragile and conflict affected situations?
Provide a short and direct response. 0.19. What is the ratio of the Cost (as % of GNI) of Coal in European Union to that in Fragile and conflict affected situations?
Offer a very short reply. 1.14. What is the ratio of the Cost (as % of GNI) of Minerals in European Union to that in Fragile and conflict affected situations?
Offer a very short reply. 0.01. What is the ratio of the Cost (as % of GNI) of Energy in European Union to that in Fragile and conflict affected situations?
Provide a succinct answer. 0.42. What is the ratio of the Cost (as % of GNI) of Water in European Union to that in Fragile and conflict affected situations?
Your answer should be very brief. 0.26. What is the difference between the highest and the second highest Cost (as % of GNI) of Coal?
Ensure brevity in your answer.  0.82. What is the difference between the highest and the second highest Cost (as % of GNI) of Minerals?
Keep it short and to the point. 0.16. What is the difference between the highest and the second highest Cost (as % of GNI) of Energy?
Provide a succinct answer. 8.61. What is the difference between the highest and the second highest Cost (as % of GNI) of Water?
Your answer should be very brief. 8.59. What is the difference between the highest and the lowest Cost (as % of GNI) of Coal?
Offer a very short reply. 1.14. What is the difference between the highest and the lowest Cost (as % of GNI) in Minerals?
Offer a very short reply. 0.57. What is the difference between the highest and the lowest Cost (as % of GNI) in Energy?
Your answer should be compact. 10.58. What is the difference between the highest and the lowest Cost (as % of GNI) in Water?
Ensure brevity in your answer.  12.2. 